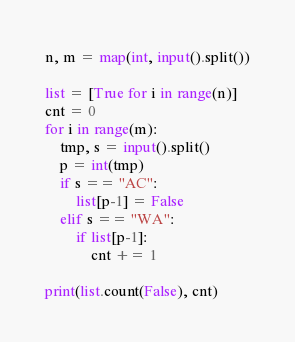<code> <loc_0><loc_0><loc_500><loc_500><_Python_>n, m = map(int, input().split())

list = [True for i in range(n)]
cnt = 0
for i in range(m):
	tmp, s = input().split()
	p = int(tmp)
	if s == "AC":
		list[p-1] = False
	elif s == "WA":
		if list[p-1]:
			cnt += 1
			
print(list.count(False), cnt)
</code> 